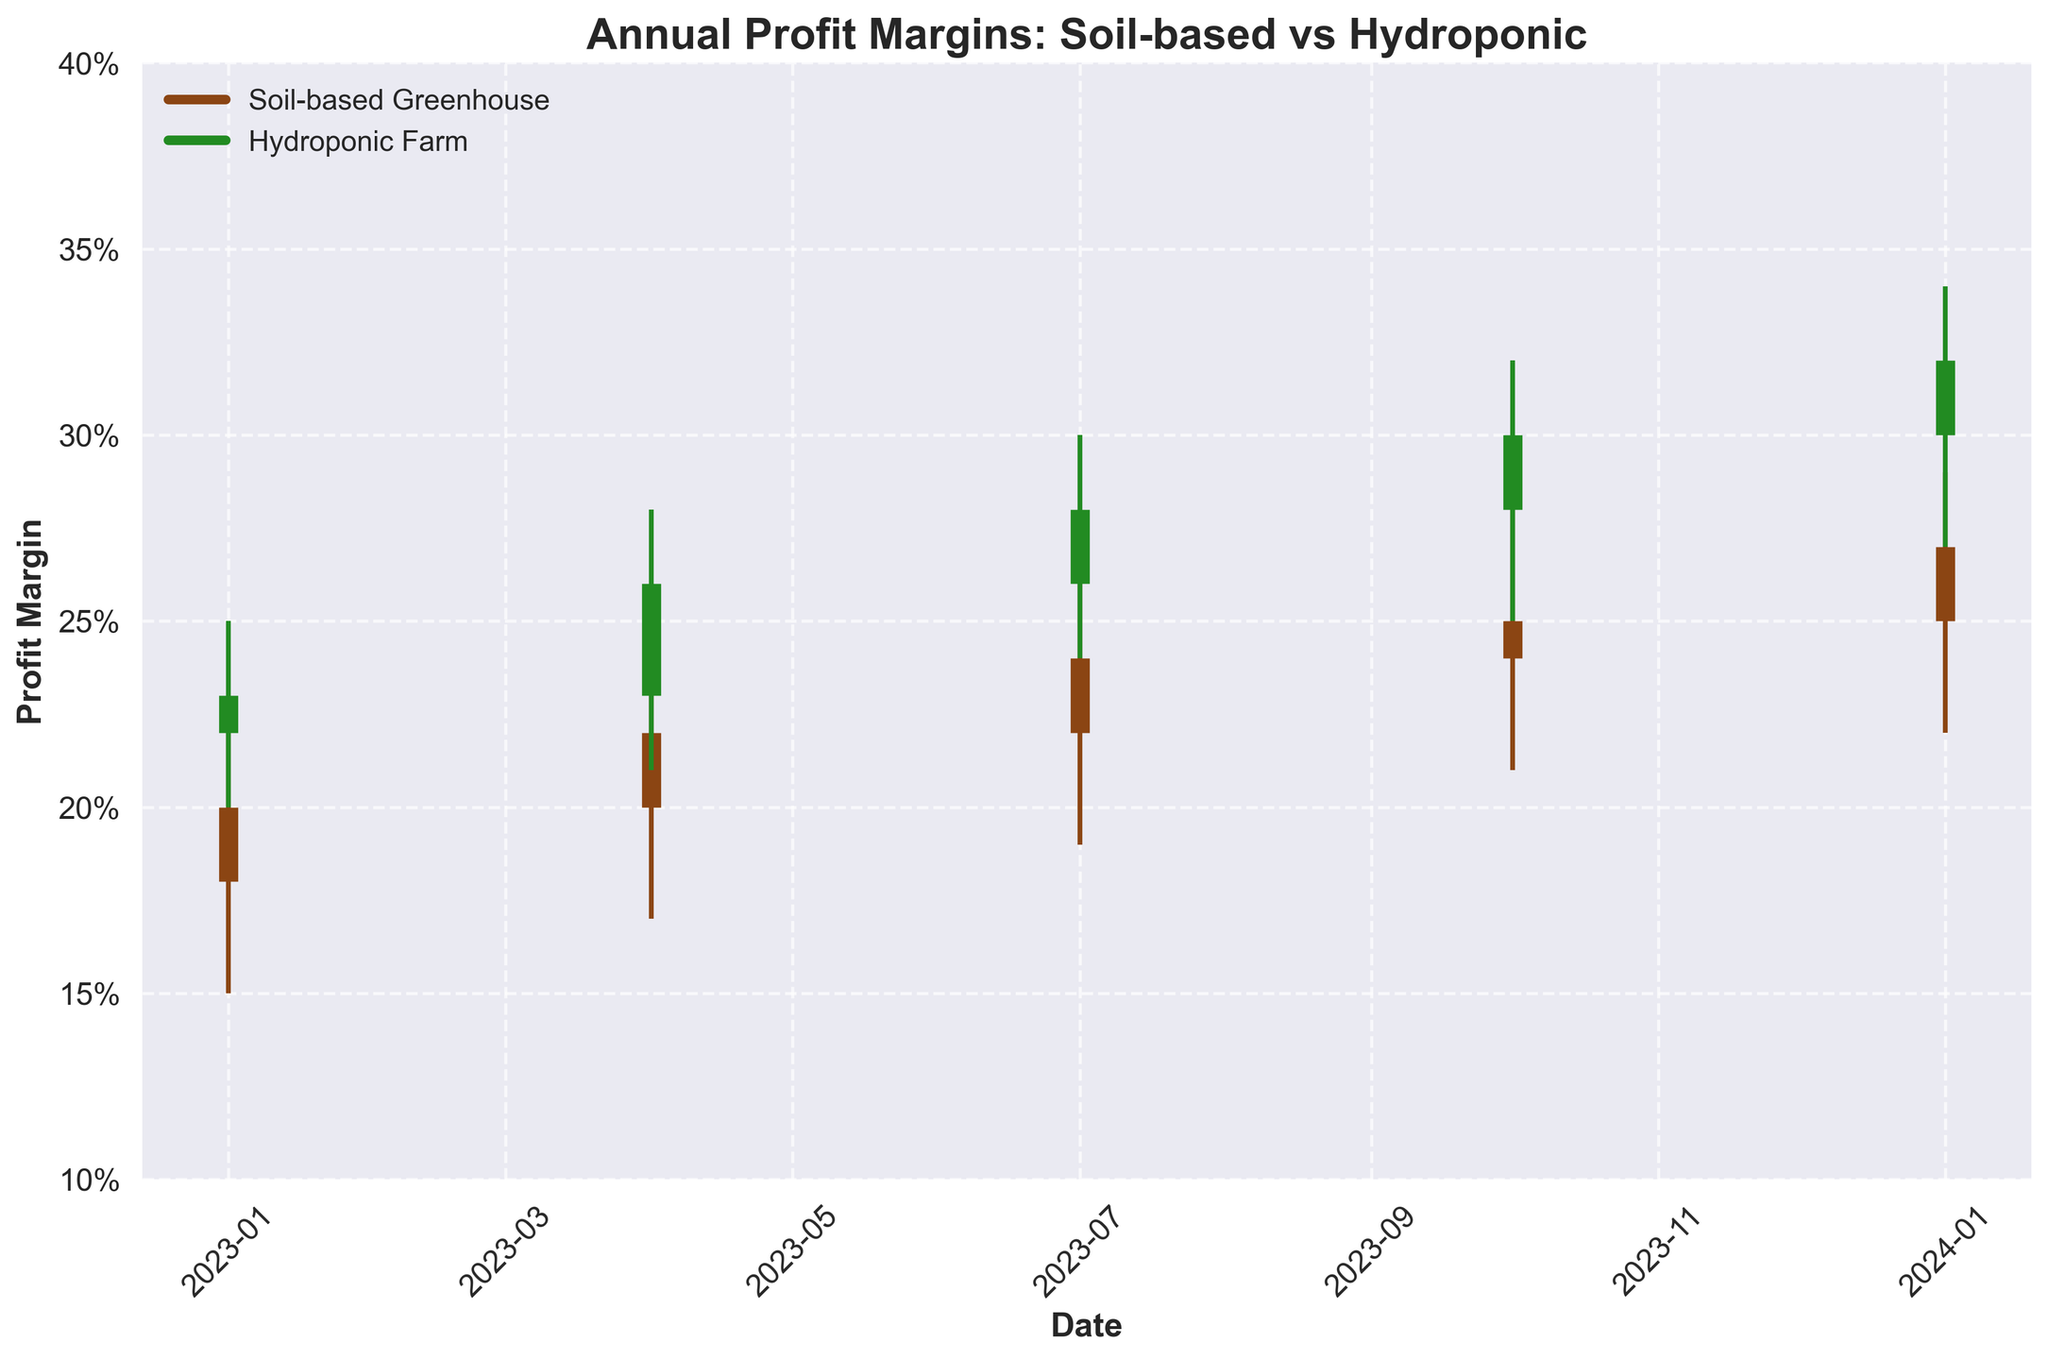What is the title of the plot? The title of the plot is displayed at the top of the figure, which reads "Annual Profit Margins: Soil-based vs Hydroponic".
Answer: Annual Profit Margins: Soil-based vs Hydroponic What is the highest closed profit margin recorded by Soil-based Greenhouse operations within the shown period? To determine the highest closed profit margin, look at the ‘Close’ values for Soil-based Greenhouse across all dates. The highest value is 0.27, recorded on 2024-01-01.
Answer: 0.27 In the most recent data point on 2024-01-01, which operation, Soil-based Greenhouse or Hydroponic Farm, has a higher high value? Compare the 'High' values for both operations on 2024-01-01. Soil-based Greenhouse has a high value of 0.29, while Hydroponic Farm has a high value of 0.34, so Hydroponic Farm has a higher high value.
Answer: Hydroponic Farm What is the color representing Hydroponic Farm in the chart? Look at the legend in the chart; it indicates that Hydroponic Farm is represented by the green color shown by its label.
Answer: Green How does the profit margin trend of Soil-based Greenhouses from 2023-01-01 to 2023-10-01 compare to that of Hydroponic Farms? Observe the 'Close' values over the dates. For Soil-based Greenhouses, the profit margin increases from 0.20 to 0.25. For Hydroponic Farms, it increases from 0.23 to 0.30. Both trends show an increase, but Hydroponic Farms have a slightly higher increase.
Answer: Both increased; Hydroponic increased more What is the difference in the low value of Hydroponic Farms between 2023-04-01 and 2023-07-01? Observe the 'Low' values for Hydroponic Farms on the specified dates. On 2023-04-01, the low value is 0.21, and on 2023-07-01, it is 0.24. The difference is 0.24 - 0.21 = 0.03.
Answer: 0.03 Which quarter of 2023 saw the highest profit margin (close value) for Soil-based Greenhouses? Compare the 'Close' values for Soil-based Greenhouses in each quarter of 2023. The highest close value is 0.25 in 2023-10-01.
Answer: Q4 (2023-10-01) What is the overall trend for Hydroponic Farms’ profit margins from 2023-01-01 to 2024-01-01? Observe the 'Close' values of Hydroponic Farms across the dates. The values are 0.23 (2023-01-01), 0.26 (2023-04-01), 0.28 (2023-07-01), 0.30 (2023-10-01), and 0.32 (2024-01-01). The trend shows a consistent increase.
Answer: Increasing How many data points are plotted for each operation? By looking at the number of vertical lines (representing dates) for each operation, there are 5 data points each for Soil-based Greenhouse and Hydroponic Farm.
Answer: 5 Which operation exhibits a larger range of profit margins from the lowest low to the highest high across the period? Calculate the range for both operations. For Soil-based Greenhouse, the range is 0.28 - 0.15 = 0.13. For Hydroponic Farm, the range is 0.34 - 0.20 = 0.14. Hydroponic Farms have a larger range.
Answer: Hydroponic Farms 